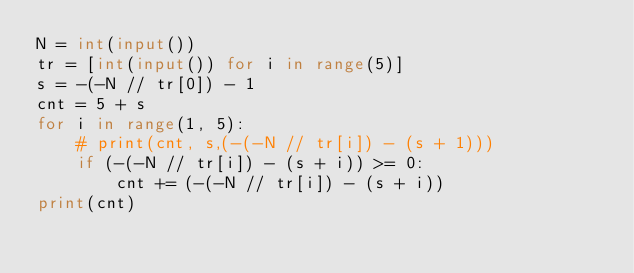Convert code to text. <code><loc_0><loc_0><loc_500><loc_500><_Python_>N = int(input())
tr = [int(input()) for i in range(5)]
s = -(-N // tr[0]) - 1
cnt = 5 + s
for i in range(1, 5):
    # print(cnt, s,(-(-N // tr[i]) - (s + 1)))
    if (-(-N // tr[i]) - (s + i)) >= 0:
        cnt += (-(-N // tr[i]) - (s + i))
print(cnt)
</code> 